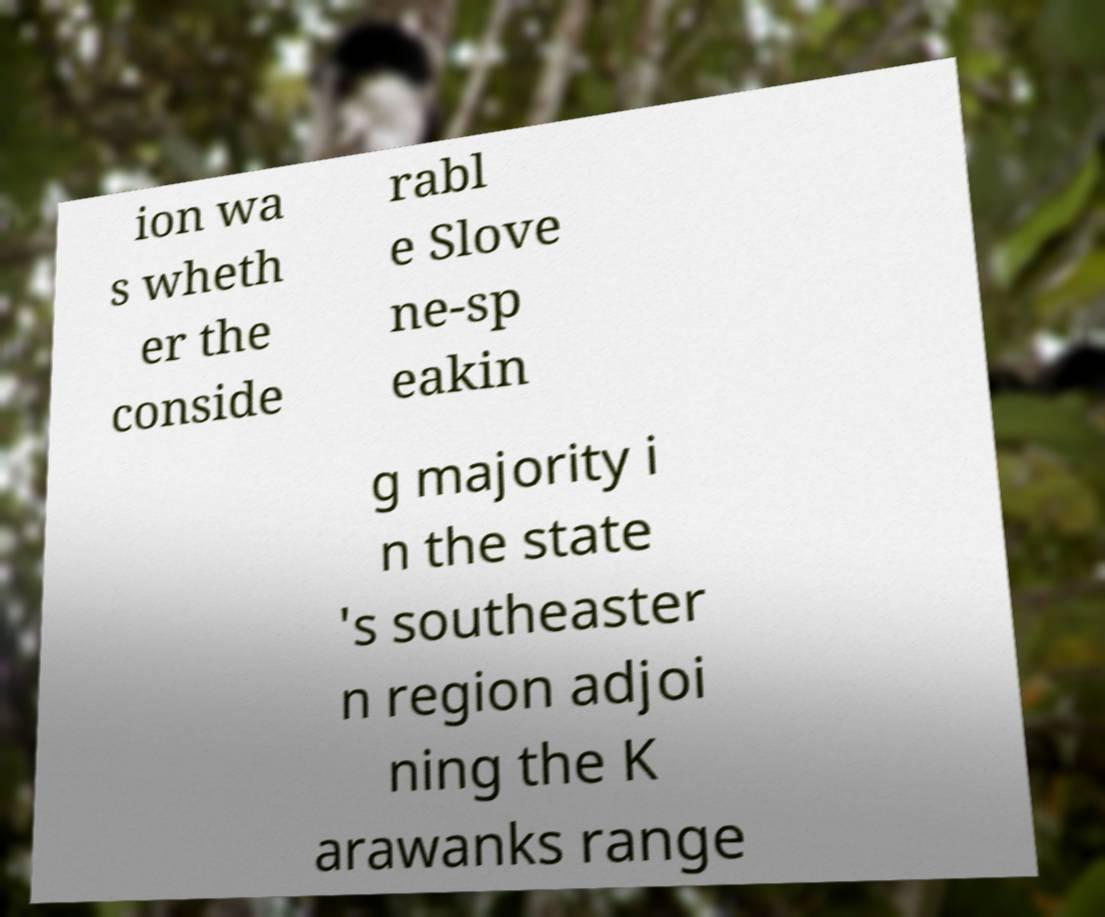Could you extract and type out the text from this image? ion wa s wheth er the conside rabl e Slove ne-sp eakin g majority i n the state 's southeaster n region adjoi ning the K arawanks range 